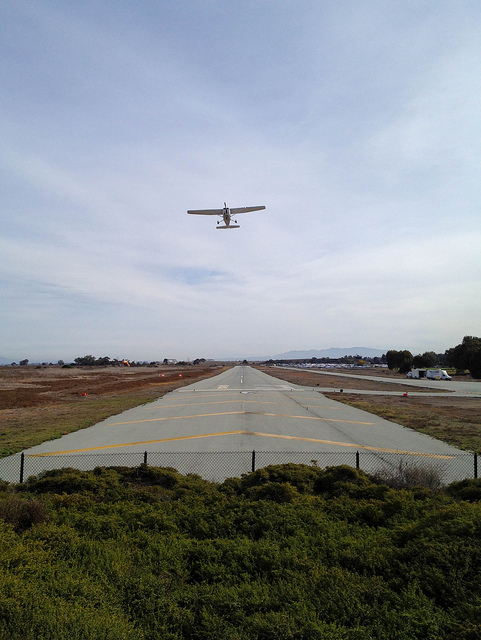<image>What defense is on top of the fence? It is unclear what defense is on top of the fence. It could be spikes or barbed wire, or there might be nothing. What is the land formation in the background of the picture? It is ambiguous. The land formation in the background of the picture can be flat land, trees, mountain or runway. Can a body of water be seen in this picture? No, a body of water cannot be seen in this picture. What defense is on top of the fence? It is unanswerable what defense is on top of the fence. What is the land formation in the background of the picture? I can't determine the land formation in the background of the picture. Can a body of water be seen in this picture? No, a body of water cannot be seen in this picture. 